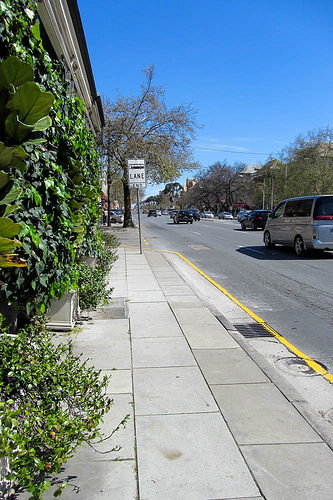<image>
Is there a car next to the sign? Yes. The car is positioned adjacent to the sign, located nearby in the same general area. 